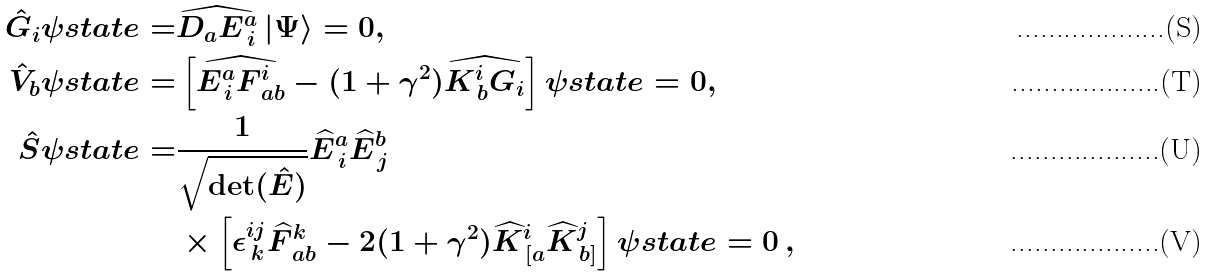Convert formula to latex. <formula><loc_0><loc_0><loc_500><loc_500>\hat { G } _ { i } \psi s t a t e = & \widehat { D _ { a } E ^ { a } _ { \, i } } \left | \Psi \right > = 0 , \\ \hat { V } _ { b } \psi s t a t e = & \left [ \widehat { E ^ { a } _ { \, i } F ^ { i } _ { \, a b } } - ( 1 + \gamma ^ { 2 } ) \widehat { K ^ { i } _ { \, b } G _ { i } } \right ] \psi s t a t e = 0 , \\ \hat { S } \psi s t a t e = & \frac { 1 } { \sqrt { \det ( \hat { E } ) } } \widehat { E } ^ { a } _ { \, i } \widehat { E } ^ { b } _ { \, j } \\ & \times \left [ \epsilon ^ { i j } _ { \, k } \widehat { F } ^ { k } _ { \, a b } - 2 ( 1 + \gamma ^ { 2 } ) \widehat { K } ^ { i } _ { \, [ a } \widehat { K } ^ { j } _ { \, b ] } \right ] \psi s t a t e = 0 \, ,</formula> 